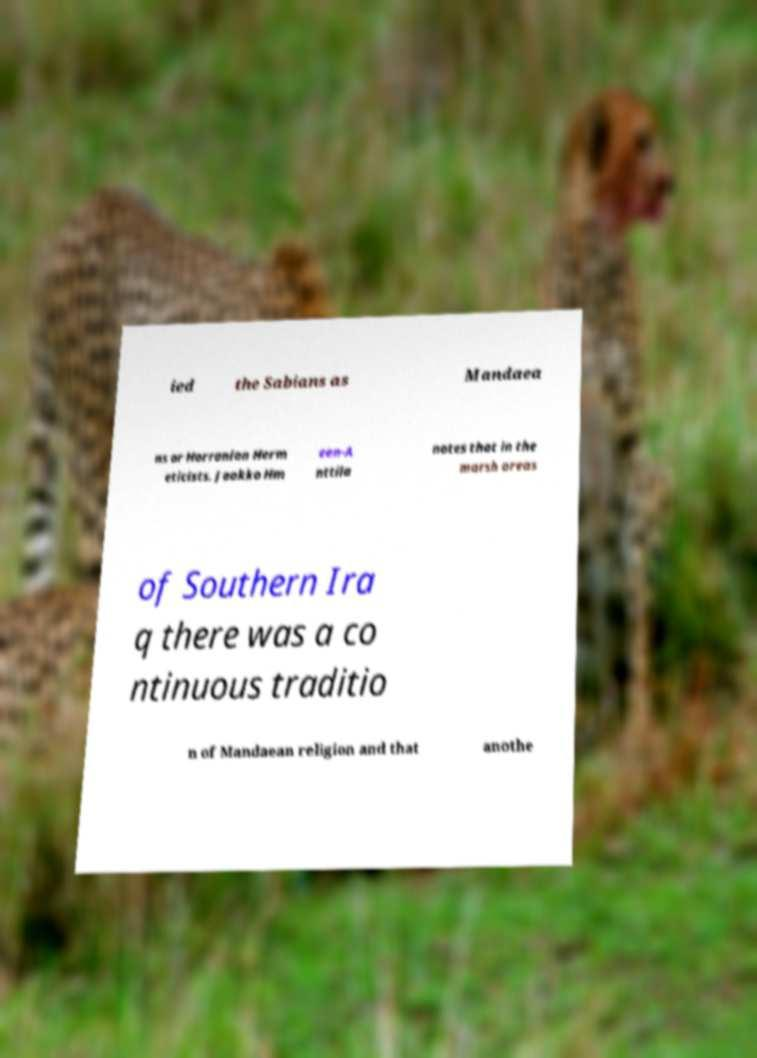Can you accurately transcribe the text from the provided image for me? ied the Sabians as Mandaea ns or Harranian Herm eticists. Jaakko Hm een-A nttila notes that in the marsh areas of Southern Ira q there was a co ntinuous traditio n of Mandaean religion and that anothe 